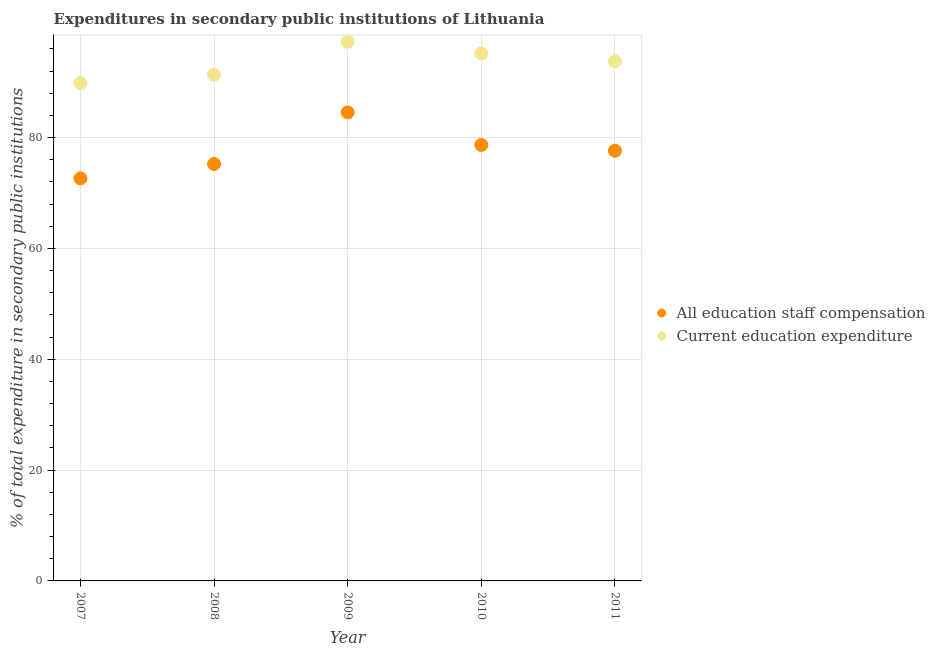How many different coloured dotlines are there?
Your response must be concise. 2. Is the number of dotlines equal to the number of legend labels?
Keep it short and to the point. Yes. What is the expenditure in staff compensation in 2009?
Make the answer very short. 84.55. Across all years, what is the maximum expenditure in staff compensation?
Offer a very short reply. 84.55. Across all years, what is the minimum expenditure in staff compensation?
Your response must be concise. 72.64. In which year was the expenditure in staff compensation maximum?
Offer a very short reply. 2009. In which year was the expenditure in education minimum?
Provide a succinct answer. 2007. What is the total expenditure in staff compensation in the graph?
Give a very brief answer. 388.74. What is the difference between the expenditure in education in 2009 and that in 2010?
Offer a terse response. 2.13. What is the difference between the expenditure in education in 2011 and the expenditure in staff compensation in 2009?
Make the answer very short. 9.23. What is the average expenditure in education per year?
Give a very brief answer. 93.49. In the year 2010, what is the difference between the expenditure in staff compensation and expenditure in education?
Give a very brief answer. -16.5. What is the ratio of the expenditure in education in 2007 to that in 2008?
Give a very brief answer. 0.98. Is the expenditure in education in 2007 less than that in 2011?
Your answer should be compact. Yes. What is the difference between the highest and the second highest expenditure in education?
Your response must be concise. 2.13. What is the difference between the highest and the lowest expenditure in staff compensation?
Your answer should be compact. 11.91. Is the sum of the expenditure in staff compensation in 2008 and 2010 greater than the maximum expenditure in education across all years?
Keep it short and to the point. Yes. Does the expenditure in staff compensation monotonically increase over the years?
Keep it short and to the point. No. Is the expenditure in education strictly greater than the expenditure in staff compensation over the years?
Ensure brevity in your answer.  Yes. Is the expenditure in staff compensation strictly less than the expenditure in education over the years?
Offer a very short reply. Yes. Does the graph contain grids?
Keep it short and to the point. Yes. How many legend labels are there?
Provide a short and direct response. 2. How are the legend labels stacked?
Your response must be concise. Vertical. What is the title of the graph?
Your response must be concise. Expenditures in secondary public institutions of Lithuania. Does "Measles" appear as one of the legend labels in the graph?
Keep it short and to the point. No. What is the label or title of the Y-axis?
Your answer should be very brief. % of total expenditure in secondary public institutions. What is the % of total expenditure in secondary public institutions in All education staff compensation in 2007?
Offer a terse response. 72.64. What is the % of total expenditure in secondary public institutions of Current education expenditure in 2007?
Offer a very short reply. 89.84. What is the % of total expenditure in secondary public institutions of All education staff compensation in 2008?
Ensure brevity in your answer.  75.25. What is the % of total expenditure in secondary public institutions in Current education expenditure in 2008?
Offer a very short reply. 91.36. What is the % of total expenditure in secondary public institutions in All education staff compensation in 2009?
Offer a very short reply. 84.55. What is the % of total expenditure in secondary public institutions in Current education expenditure in 2009?
Keep it short and to the point. 97.3. What is the % of total expenditure in secondary public institutions of All education staff compensation in 2010?
Your answer should be compact. 78.68. What is the % of total expenditure in secondary public institutions of Current education expenditure in 2010?
Your answer should be very brief. 95.18. What is the % of total expenditure in secondary public institutions in All education staff compensation in 2011?
Your answer should be compact. 77.63. What is the % of total expenditure in secondary public institutions of Current education expenditure in 2011?
Offer a very short reply. 93.78. Across all years, what is the maximum % of total expenditure in secondary public institutions in All education staff compensation?
Your answer should be very brief. 84.55. Across all years, what is the maximum % of total expenditure in secondary public institutions in Current education expenditure?
Give a very brief answer. 97.3. Across all years, what is the minimum % of total expenditure in secondary public institutions in All education staff compensation?
Give a very brief answer. 72.64. Across all years, what is the minimum % of total expenditure in secondary public institutions of Current education expenditure?
Your answer should be compact. 89.84. What is the total % of total expenditure in secondary public institutions in All education staff compensation in the graph?
Offer a terse response. 388.74. What is the total % of total expenditure in secondary public institutions of Current education expenditure in the graph?
Provide a succinct answer. 467.47. What is the difference between the % of total expenditure in secondary public institutions in All education staff compensation in 2007 and that in 2008?
Ensure brevity in your answer.  -2.61. What is the difference between the % of total expenditure in secondary public institutions of Current education expenditure in 2007 and that in 2008?
Give a very brief answer. -1.52. What is the difference between the % of total expenditure in secondary public institutions of All education staff compensation in 2007 and that in 2009?
Your answer should be compact. -11.91. What is the difference between the % of total expenditure in secondary public institutions of Current education expenditure in 2007 and that in 2009?
Give a very brief answer. -7.46. What is the difference between the % of total expenditure in secondary public institutions of All education staff compensation in 2007 and that in 2010?
Offer a very short reply. -6.04. What is the difference between the % of total expenditure in secondary public institutions in Current education expenditure in 2007 and that in 2010?
Your answer should be compact. -5.33. What is the difference between the % of total expenditure in secondary public institutions of All education staff compensation in 2007 and that in 2011?
Offer a terse response. -4.99. What is the difference between the % of total expenditure in secondary public institutions in Current education expenditure in 2007 and that in 2011?
Offer a very short reply. -3.94. What is the difference between the % of total expenditure in secondary public institutions of All education staff compensation in 2008 and that in 2009?
Offer a terse response. -9.3. What is the difference between the % of total expenditure in secondary public institutions in Current education expenditure in 2008 and that in 2009?
Provide a succinct answer. -5.94. What is the difference between the % of total expenditure in secondary public institutions of All education staff compensation in 2008 and that in 2010?
Offer a very short reply. -3.43. What is the difference between the % of total expenditure in secondary public institutions of Current education expenditure in 2008 and that in 2010?
Offer a terse response. -3.82. What is the difference between the % of total expenditure in secondary public institutions of All education staff compensation in 2008 and that in 2011?
Your response must be concise. -2.38. What is the difference between the % of total expenditure in secondary public institutions of Current education expenditure in 2008 and that in 2011?
Your answer should be very brief. -2.42. What is the difference between the % of total expenditure in secondary public institutions of All education staff compensation in 2009 and that in 2010?
Your answer should be very brief. 5.87. What is the difference between the % of total expenditure in secondary public institutions in Current education expenditure in 2009 and that in 2010?
Your answer should be very brief. 2.13. What is the difference between the % of total expenditure in secondary public institutions in All education staff compensation in 2009 and that in 2011?
Offer a terse response. 6.92. What is the difference between the % of total expenditure in secondary public institutions in Current education expenditure in 2009 and that in 2011?
Your answer should be very brief. 3.52. What is the difference between the % of total expenditure in secondary public institutions of All education staff compensation in 2010 and that in 2011?
Provide a short and direct response. 1.05. What is the difference between the % of total expenditure in secondary public institutions in Current education expenditure in 2010 and that in 2011?
Your response must be concise. 1.39. What is the difference between the % of total expenditure in secondary public institutions of All education staff compensation in 2007 and the % of total expenditure in secondary public institutions of Current education expenditure in 2008?
Keep it short and to the point. -18.72. What is the difference between the % of total expenditure in secondary public institutions in All education staff compensation in 2007 and the % of total expenditure in secondary public institutions in Current education expenditure in 2009?
Give a very brief answer. -24.66. What is the difference between the % of total expenditure in secondary public institutions of All education staff compensation in 2007 and the % of total expenditure in secondary public institutions of Current education expenditure in 2010?
Give a very brief answer. -22.54. What is the difference between the % of total expenditure in secondary public institutions in All education staff compensation in 2007 and the % of total expenditure in secondary public institutions in Current education expenditure in 2011?
Ensure brevity in your answer.  -21.14. What is the difference between the % of total expenditure in secondary public institutions in All education staff compensation in 2008 and the % of total expenditure in secondary public institutions in Current education expenditure in 2009?
Ensure brevity in your answer.  -22.05. What is the difference between the % of total expenditure in secondary public institutions in All education staff compensation in 2008 and the % of total expenditure in secondary public institutions in Current education expenditure in 2010?
Give a very brief answer. -19.93. What is the difference between the % of total expenditure in secondary public institutions of All education staff compensation in 2008 and the % of total expenditure in secondary public institutions of Current education expenditure in 2011?
Ensure brevity in your answer.  -18.53. What is the difference between the % of total expenditure in secondary public institutions in All education staff compensation in 2009 and the % of total expenditure in secondary public institutions in Current education expenditure in 2010?
Provide a succinct answer. -10.63. What is the difference between the % of total expenditure in secondary public institutions in All education staff compensation in 2009 and the % of total expenditure in secondary public institutions in Current education expenditure in 2011?
Your answer should be compact. -9.23. What is the difference between the % of total expenditure in secondary public institutions in All education staff compensation in 2010 and the % of total expenditure in secondary public institutions in Current education expenditure in 2011?
Provide a succinct answer. -15.11. What is the average % of total expenditure in secondary public institutions in All education staff compensation per year?
Keep it short and to the point. 77.75. What is the average % of total expenditure in secondary public institutions in Current education expenditure per year?
Provide a short and direct response. 93.49. In the year 2007, what is the difference between the % of total expenditure in secondary public institutions in All education staff compensation and % of total expenditure in secondary public institutions in Current education expenditure?
Provide a succinct answer. -17.2. In the year 2008, what is the difference between the % of total expenditure in secondary public institutions of All education staff compensation and % of total expenditure in secondary public institutions of Current education expenditure?
Your response must be concise. -16.11. In the year 2009, what is the difference between the % of total expenditure in secondary public institutions of All education staff compensation and % of total expenditure in secondary public institutions of Current education expenditure?
Your answer should be compact. -12.75. In the year 2010, what is the difference between the % of total expenditure in secondary public institutions in All education staff compensation and % of total expenditure in secondary public institutions in Current education expenditure?
Provide a short and direct response. -16.5. In the year 2011, what is the difference between the % of total expenditure in secondary public institutions in All education staff compensation and % of total expenditure in secondary public institutions in Current education expenditure?
Offer a very short reply. -16.16. What is the ratio of the % of total expenditure in secondary public institutions of All education staff compensation in 2007 to that in 2008?
Offer a terse response. 0.97. What is the ratio of the % of total expenditure in secondary public institutions in Current education expenditure in 2007 to that in 2008?
Provide a succinct answer. 0.98. What is the ratio of the % of total expenditure in secondary public institutions in All education staff compensation in 2007 to that in 2009?
Your answer should be compact. 0.86. What is the ratio of the % of total expenditure in secondary public institutions in Current education expenditure in 2007 to that in 2009?
Your answer should be very brief. 0.92. What is the ratio of the % of total expenditure in secondary public institutions of All education staff compensation in 2007 to that in 2010?
Offer a terse response. 0.92. What is the ratio of the % of total expenditure in secondary public institutions in Current education expenditure in 2007 to that in 2010?
Give a very brief answer. 0.94. What is the ratio of the % of total expenditure in secondary public institutions of All education staff compensation in 2007 to that in 2011?
Your answer should be very brief. 0.94. What is the ratio of the % of total expenditure in secondary public institutions of Current education expenditure in 2007 to that in 2011?
Provide a succinct answer. 0.96. What is the ratio of the % of total expenditure in secondary public institutions of All education staff compensation in 2008 to that in 2009?
Your response must be concise. 0.89. What is the ratio of the % of total expenditure in secondary public institutions in Current education expenditure in 2008 to that in 2009?
Make the answer very short. 0.94. What is the ratio of the % of total expenditure in secondary public institutions in All education staff compensation in 2008 to that in 2010?
Make the answer very short. 0.96. What is the ratio of the % of total expenditure in secondary public institutions of Current education expenditure in 2008 to that in 2010?
Make the answer very short. 0.96. What is the ratio of the % of total expenditure in secondary public institutions in All education staff compensation in 2008 to that in 2011?
Give a very brief answer. 0.97. What is the ratio of the % of total expenditure in secondary public institutions of Current education expenditure in 2008 to that in 2011?
Your response must be concise. 0.97. What is the ratio of the % of total expenditure in secondary public institutions of All education staff compensation in 2009 to that in 2010?
Provide a succinct answer. 1.07. What is the ratio of the % of total expenditure in secondary public institutions in Current education expenditure in 2009 to that in 2010?
Your response must be concise. 1.02. What is the ratio of the % of total expenditure in secondary public institutions in All education staff compensation in 2009 to that in 2011?
Give a very brief answer. 1.09. What is the ratio of the % of total expenditure in secondary public institutions of Current education expenditure in 2009 to that in 2011?
Make the answer very short. 1.04. What is the ratio of the % of total expenditure in secondary public institutions in All education staff compensation in 2010 to that in 2011?
Offer a terse response. 1.01. What is the ratio of the % of total expenditure in secondary public institutions of Current education expenditure in 2010 to that in 2011?
Provide a short and direct response. 1.01. What is the difference between the highest and the second highest % of total expenditure in secondary public institutions of All education staff compensation?
Ensure brevity in your answer.  5.87. What is the difference between the highest and the second highest % of total expenditure in secondary public institutions of Current education expenditure?
Your answer should be very brief. 2.13. What is the difference between the highest and the lowest % of total expenditure in secondary public institutions of All education staff compensation?
Give a very brief answer. 11.91. What is the difference between the highest and the lowest % of total expenditure in secondary public institutions in Current education expenditure?
Provide a short and direct response. 7.46. 